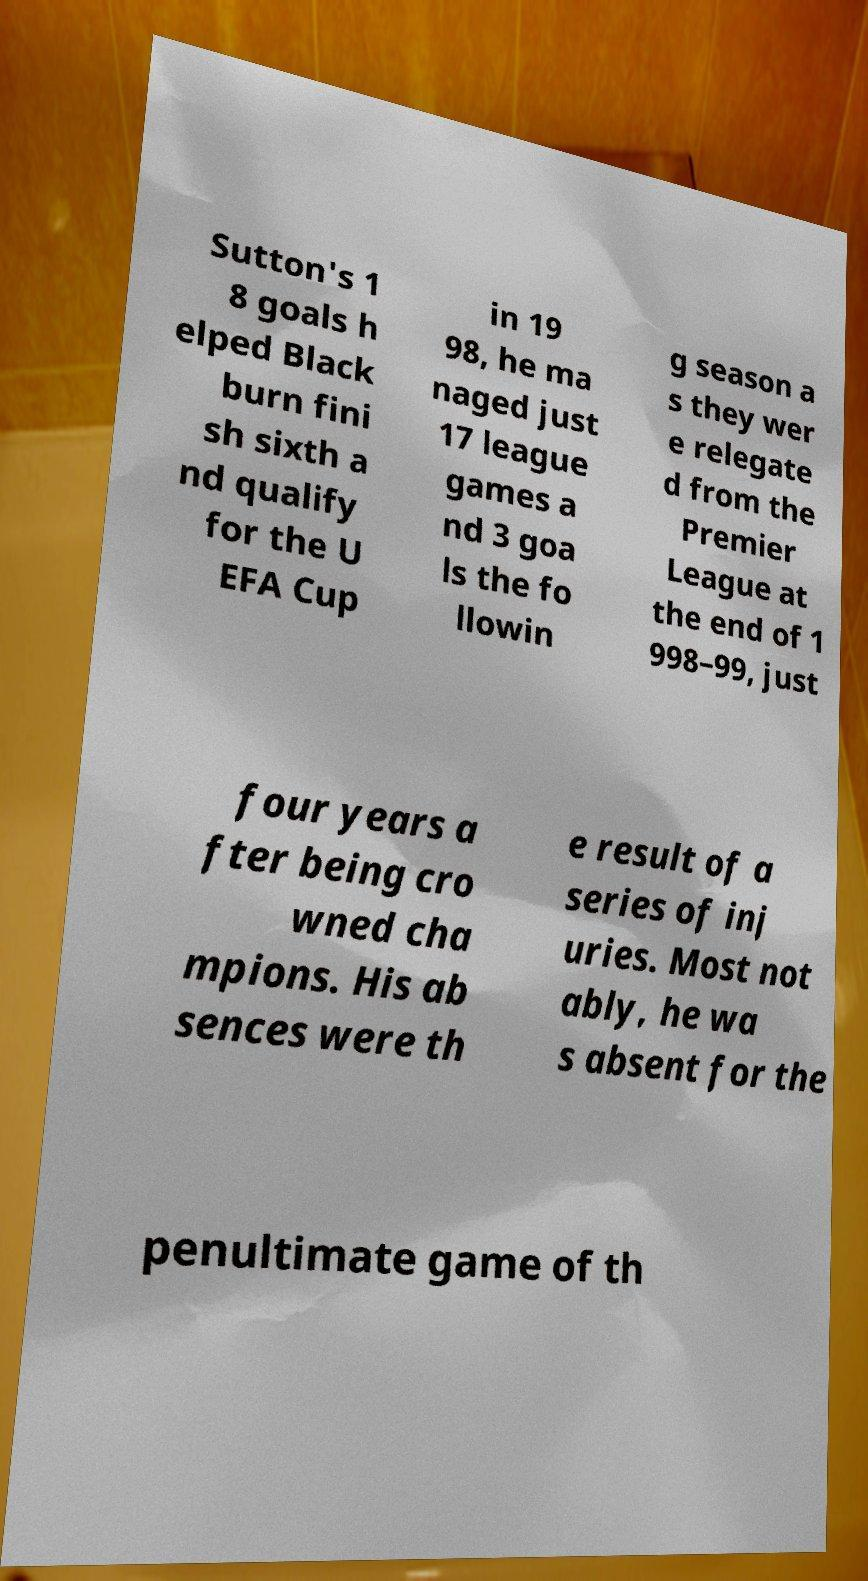Could you assist in decoding the text presented in this image and type it out clearly? Sutton's 1 8 goals h elped Black burn fini sh sixth a nd qualify for the U EFA Cup in 19 98, he ma naged just 17 league games a nd 3 goa ls the fo llowin g season a s they wer e relegate d from the Premier League at the end of 1 998–99, just four years a fter being cro wned cha mpions. His ab sences were th e result of a series of inj uries. Most not ably, he wa s absent for the penultimate game of th 